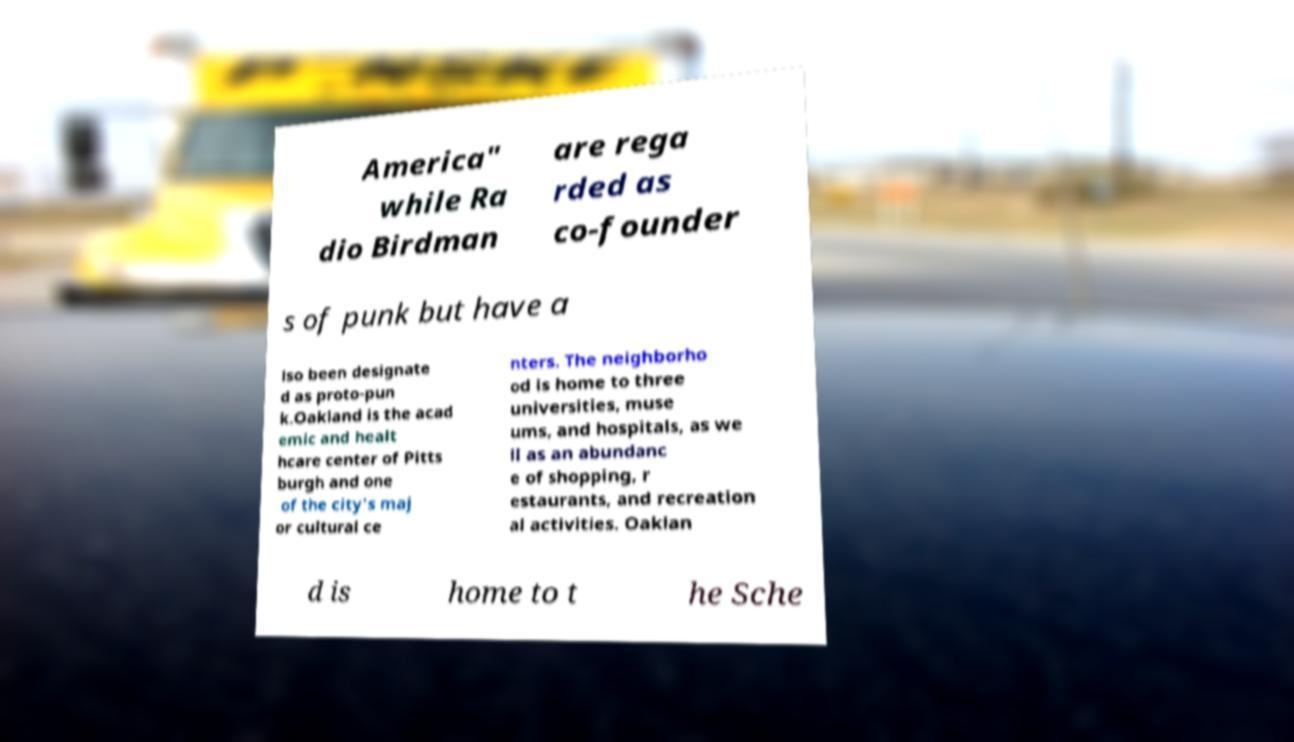Could you assist in decoding the text presented in this image and type it out clearly? America" while Ra dio Birdman are rega rded as co-founder s of punk but have a lso been designate d as proto-pun k.Oakland is the acad emic and healt hcare center of Pitts burgh and one of the city's maj or cultural ce nters. The neighborho od is home to three universities, muse ums, and hospitals, as we ll as an abundanc e of shopping, r estaurants, and recreation al activities. Oaklan d is home to t he Sche 